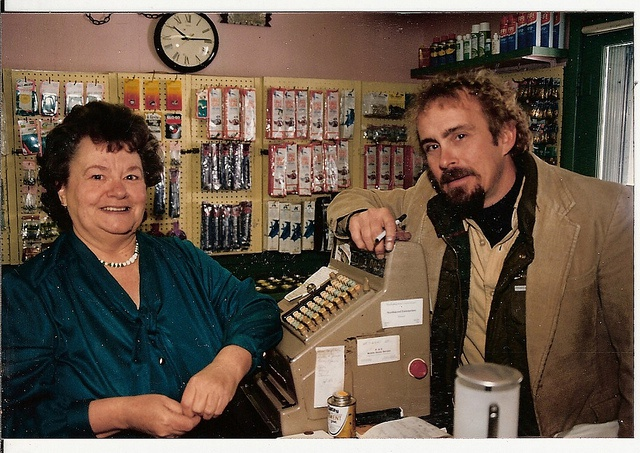Describe the objects in this image and their specific colors. I can see people in gray, black, brown, and maroon tones, people in gray, black, salmon, and darkblue tones, and clock in gray, black, and tan tones in this image. 